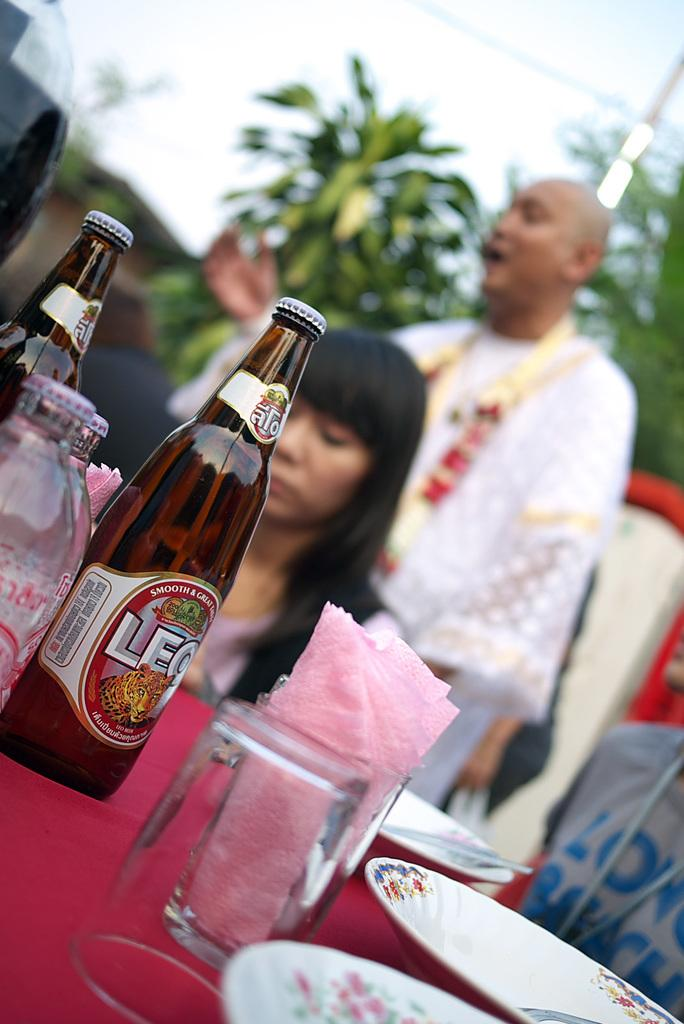What is the main object in the image? There is a table in the image. What is covering the table? The table is covered with a red cloth. What items can be seen on the table? There are glasses, bottles, and plates on the table. Can you describe the background of the image? There are three persons and trees in the background of the image. What type of nose can be seen on the person in the image? There are no visible noses in the image, as the focus is on the table and its contents. 